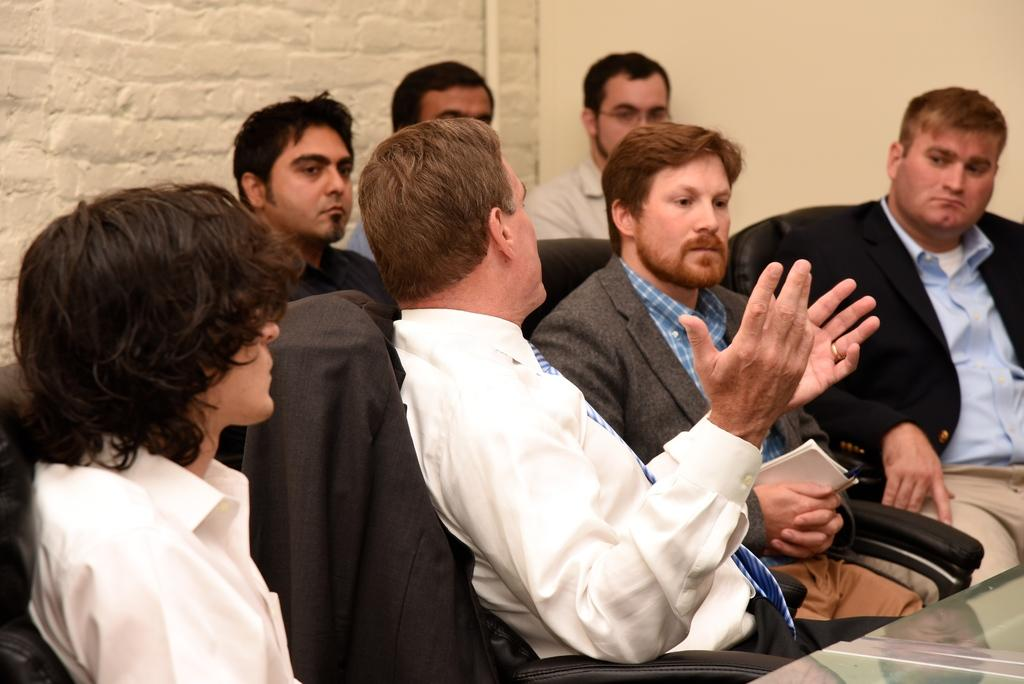How many people are present in the image? There is a woman and men in the image, so there are multiple people present. What are the people in the image doing? The woman and men are sitting at a table. What object is present at the table? There is a chair at the table. What is one of the men holding in his hands? One man is holding a book in his hands. What can be seen in the background of the image? There is a wall in the background of the image. What type of plant is growing on the table in the image? There is no plant growing on the table in the image. What achievement is the woman celebrating in the image? There is no indication of any achievement being celebrated in the image. 